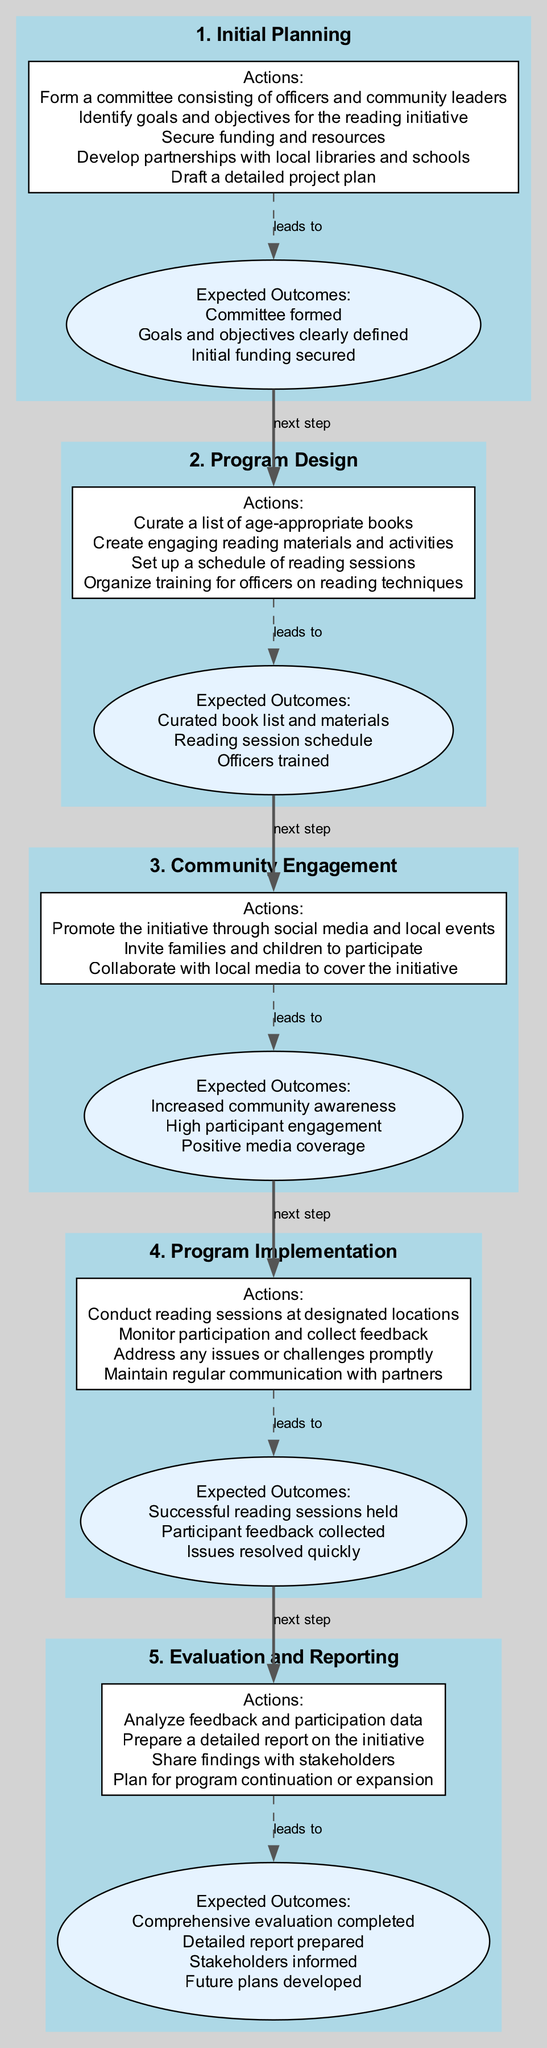What is the first step in the pathway? The first step is listed at the top of the diagram. It is labeled "1. Initial Planning."
Answer: 1. Initial Planning How many actions are there in the second step? Looking at the second step "2. Program Design," it lists four actions underneath it.
Answer: 4 What are the expected outcomes of the fourth step? The fourth step "4. Program Implementation" has specific expected outcomes listed. They are: "Successful reading sessions held," "Participant feedback collected," and "Issues resolved quickly."
Answer: Successful reading sessions held, Participant feedback collected, Issues resolved quickly Which step leads to community engagement? By following the arrows in the diagram, the step that directly proceeds to community engagement is "2. Program Design."
Answer: 2. Program Design What is the total number of steps in the pathway? The total number of steps can be counted by viewing the diagram from top to bottom. There are five distinct steps.
Answer: 5 What is the action associated with the third step? The third step is "3. Community Engagement," which has three actions listed under it. They include promoting the initiative through social media, inviting families and children to participate, and collaborating with local media.
Answer: Promote the initiative through social media and local events, Invite families and children to participate, Collaborate with local media What expected outcome follows the design of the program? The expected outcome that follows after the program design step is linked by the labeled arrow and states "Curated book list and materials," "Reading session schedule," and "Officers trained."
Answer: Curated book list and materials, Reading session schedule, Officers trained How does one step lead to the next in the pathway? Each step is connected to the next by a directed edge labeled "next step." For example, "1. Initial Planning" leads to "2. Program Design" and so on.
Answer: By directed edges labeled "next step" 